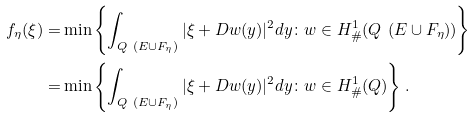Convert formula to latex. <formula><loc_0><loc_0><loc_500><loc_500>f _ { \eta } ( \xi ) = & \min \left \{ \int _ { Q \ ( E \cup F _ { \eta } ) } | \xi + D w ( y ) | ^ { 2 } d y \colon w \in H ^ { 1 } _ { \# } ( Q \ ( E \cup F _ { \eta } ) ) \right \} \\ = & \min \left \{ \int _ { Q \ ( E \cup F _ { \eta } ) } | \xi + D w ( y ) | ^ { 2 } d y \colon w \in H ^ { 1 } _ { \# } ( Q ) \right \} .</formula> 